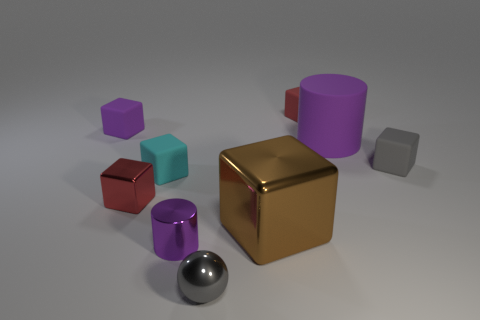Are there fewer tiny gray cubes than big green matte objects?
Offer a terse response. No. There is a thing that is on the right side of the tiny red rubber cube and in front of the big matte object; what material is it?
Keep it short and to the point. Rubber. How big is the purple rubber object that is on the right side of the red thing right of the small purple thing that is in front of the tiny purple rubber block?
Your answer should be compact. Large. Is the shape of the large purple thing the same as the small thing that is in front of the purple metal cylinder?
Your answer should be compact. No. How many objects are both to the left of the matte cylinder and behind the brown metallic thing?
Provide a succinct answer. 4. How many blue things are either metal balls or small matte blocks?
Make the answer very short. 0. There is a cylinder left of the brown object; is its color the same as the cylinder that is behind the gray block?
Give a very brief answer. Yes. What color is the tiny object that is to the right of the red object that is behind the small object that is left of the red metallic thing?
Provide a succinct answer. Gray. There is a purple rubber thing on the left side of the tiny gray metallic object; is there a matte thing behind it?
Give a very brief answer. Yes. There is a matte object that is behind the tiny purple rubber block; does it have the same shape as the cyan matte object?
Ensure brevity in your answer.  Yes. 